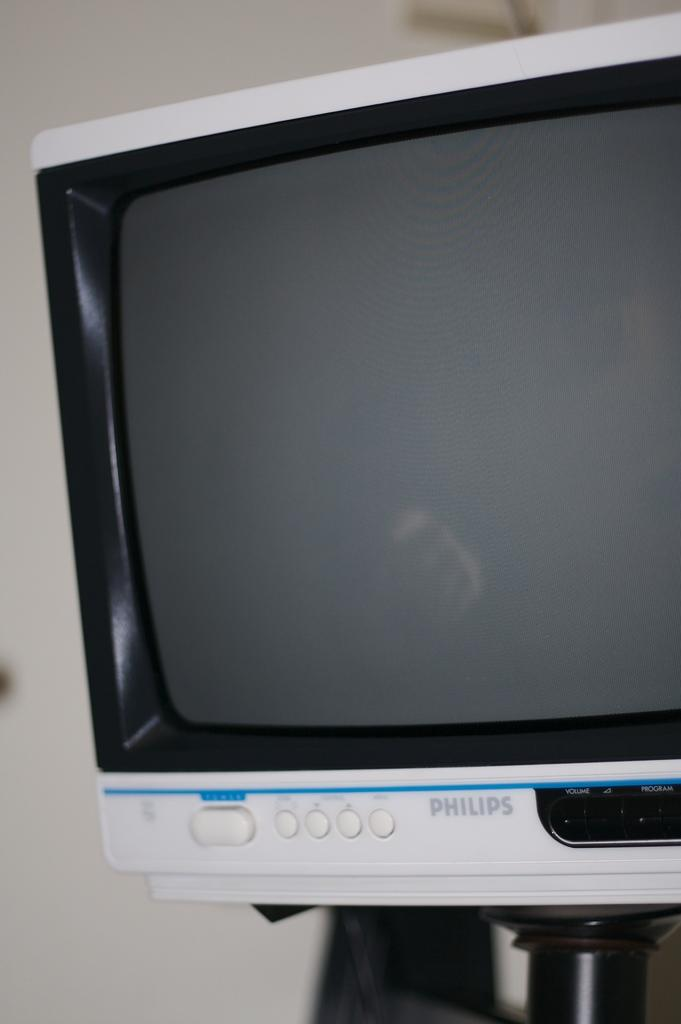Provide a one-sentence caption for the provided image. A white monitor that was manufactured by Philips shows nothing on the screen. 